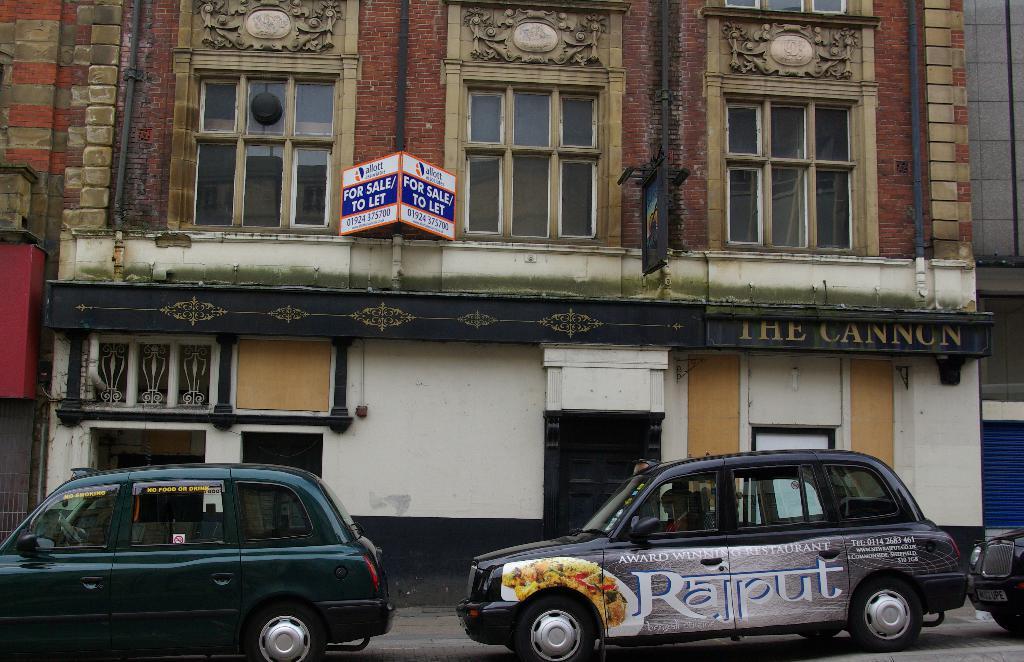Is this building for sale?
Make the answer very short. Yes. What does the car say?
Make the answer very short. Rajput. 